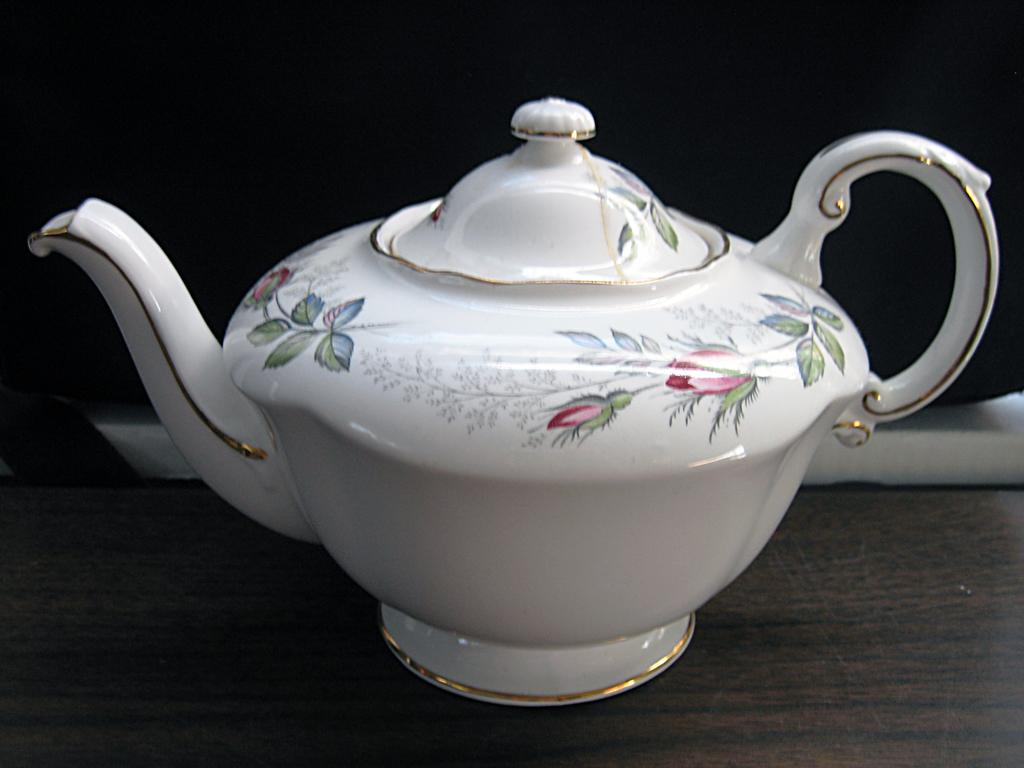What color is the kettle in the image? The kettle in the image is white-colored. Where is the kettle located in the image? The kettle is in the front of the image. What designs are present on the kettle? There are depictions of flowers and leaves on the kettle. What type of club is being used to play basketball in the image? There is no club or basketball present in the image; it only features a white-colored kettle with designs of flowers and leaves. 